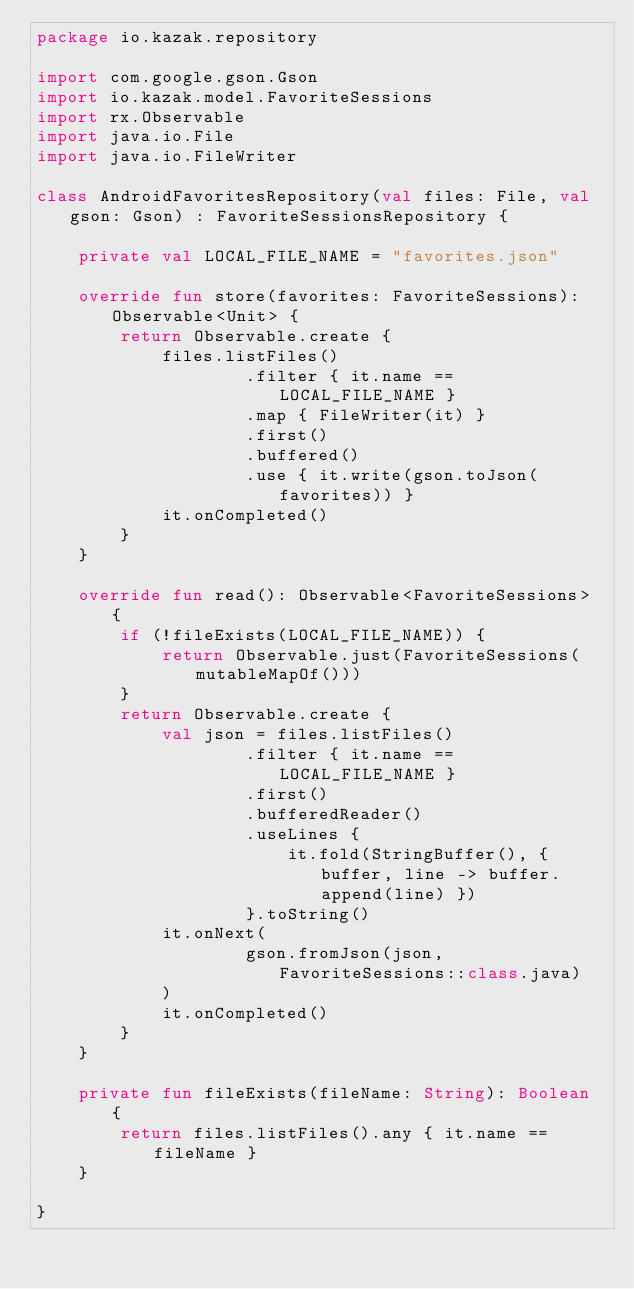Convert code to text. <code><loc_0><loc_0><loc_500><loc_500><_Kotlin_>package io.kazak.repository

import com.google.gson.Gson
import io.kazak.model.FavoriteSessions
import rx.Observable
import java.io.File
import java.io.FileWriter

class AndroidFavoritesRepository(val files: File, val gson: Gson) : FavoriteSessionsRepository {

    private val LOCAL_FILE_NAME = "favorites.json"

    override fun store(favorites: FavoriteSessions): Observable<Unit> {
        return Observable.create {
            files.listFiles()
                    .filter { it.name == LOCAL_FILE_NAME }
                    .map { FileWriter(it) }
                    .first()
                    .buffered()
                    .use { it.write(gson.toJson(favorites)) }
            it.onCompleted()
        }
    }

    override fun read(): Observable<FavoriteSessions> {
        if (!fileExists(LOCAL_FILE_NAME)) {
            return Observable.just(FavoriteSessions(mutableMapOf()))
        }
        return Observable.create {
            val json = files.listFiles()
                    .filter { it.name == LOCAL_FILE_NAME }
                    .first()
                    .bufferedReader()
                    .useLines {
                        it.fold(StringBuffer(), { buffer, line -> buffer.append(line) })
                    }.toString()
            it.onNext(
                    gson.fromJson(json, FavoriteSessions::class.java)
            )
            it.onCompleted()
        }
    }

    private fun fileExists(fileName: String): Boolean {
        return files.listFiles().any { it.name == fileName }
    }

}
</code> 